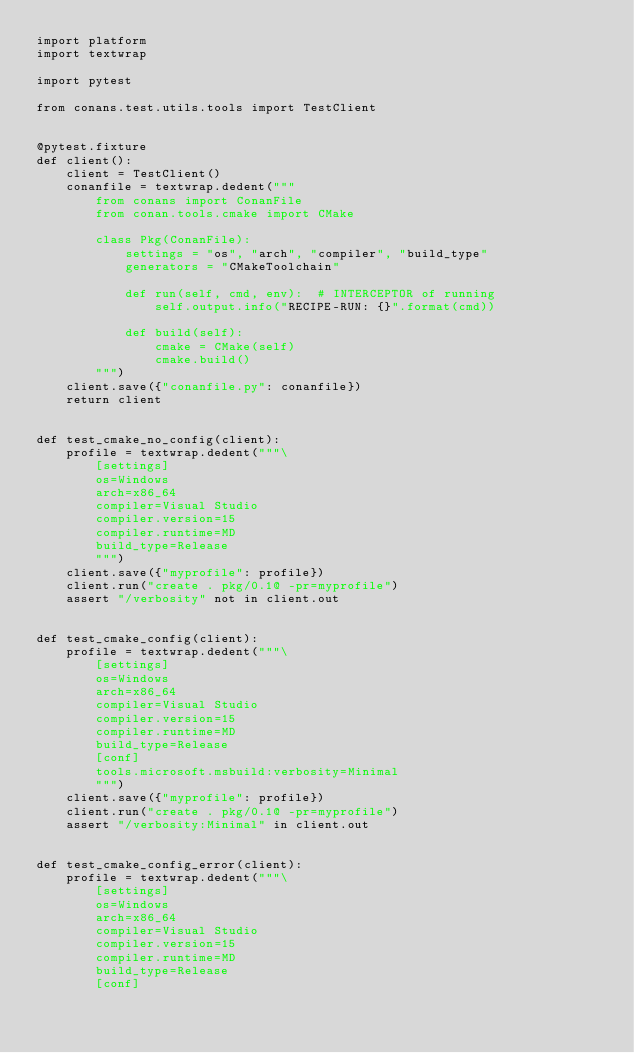Convert code to text. <code><loc_0><loc_0><loc_500><loc_500><_Python_>import platform
import textwrap

import pytest

from conans.test.utils.tools import TestClient


@pytest.fixture
def client():
    client = TestClient()
    conanfile = textwrap.dedent("""
        from conans import ConanFile
        from conan.tools.cmake import CMake

        class Pkg(ConanFile):
            settings = "os", "arch", "compiler", "build_type"
            generators = "CMakeToolchain"

            def run(self, cmd, env):  # INTERCEPTOR of running
                self.output.info("RECIPE-RUN: {}".format(cmd))

            def build(self):
                cmake = CMake(self)
                cmake.build()
        """)
    client.save({"conanfile.py": conanfile})
    return client


def test_cmake_no_config(client):
    profile = textwrap.dedent("""\
        [settings]
        os=Windows
        arch=x86_64
        compiler=Visual Studio
        compiler.version=15
        compiler.runtime=MD
        build_type=Release
        """)
    client.save({"myprofile": profile})
    client.run("create . pkg/0.1@ -pr=myprofile")
    assert "/verbosity" not in client.out


def test_cmake_config(client):
    profile = textwrap.dedent("""\
        [settings]
        os=Windows
        arch=x86_64
        compiler=Visual Studio
        compiler.version=15
        compiler.runtime=MD
        build_type=Release
        [conf]
        tools.microsoft.msbuild:verbosity=Minimal
        """)
    client.save({"myprofile": profile})
    client.run("create . pkg/0.1@ -pr=myprofile")
    assert "/verbosity:Minimal" in client.out


def test_cmake_config_error(client):
    profile = textwrap.dedent("""\
        [settings]
        os=Windows
        arch=x86_64
        compiler=Visual Studio
        compiler.version=15
        compiler.runtime=MD
        build_type=Release
        [conf]</code> 